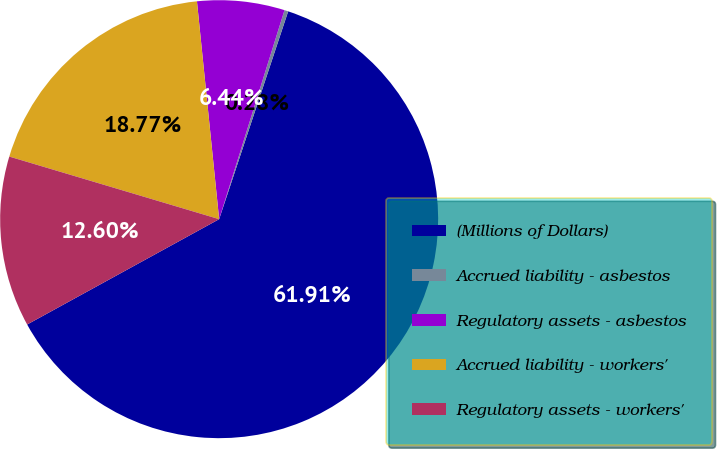<chart> <loc_0><loc_0><loc_500><loc_500><pie_chart><fcel>(Millions of Dollars)<fcel>Accrued liability - asbestos<fcel>Regulatory assets - asbestos<fcel>Accrued liability - workers'<fcel>Regulatory assets - workers'<nl><fcel>61.91%<fcel>0.28%<fcel>6.44%<fcel>18.77%<fcel>12.6%<nl></chart> 